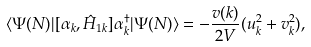Convert formula to latex. <formula><loc_0><loc_0><loc_500><loc_500>& \langle \Psi ( N ) | [ \alpha _ { k } , \hat { H } _ { 1 k } ] \alpha _ { k } ^ { \dagger } | \Psi ( N ) \rangle = - \frac { v ( { k } ) } { 2 V } ( u _ { k } ^ { 2 } + v _ { k } ^ { 2 } ) ,</formula> 